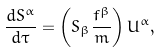<formula> <loc_0><loc_0><loc_500><loc_500>\frac { d S ^ { \alpha } } { d \tau } = \left ( S _ { \beta } \frac { f ^ { \beta } } { m } \right ) U ^ { \alpha } ,</formula> 